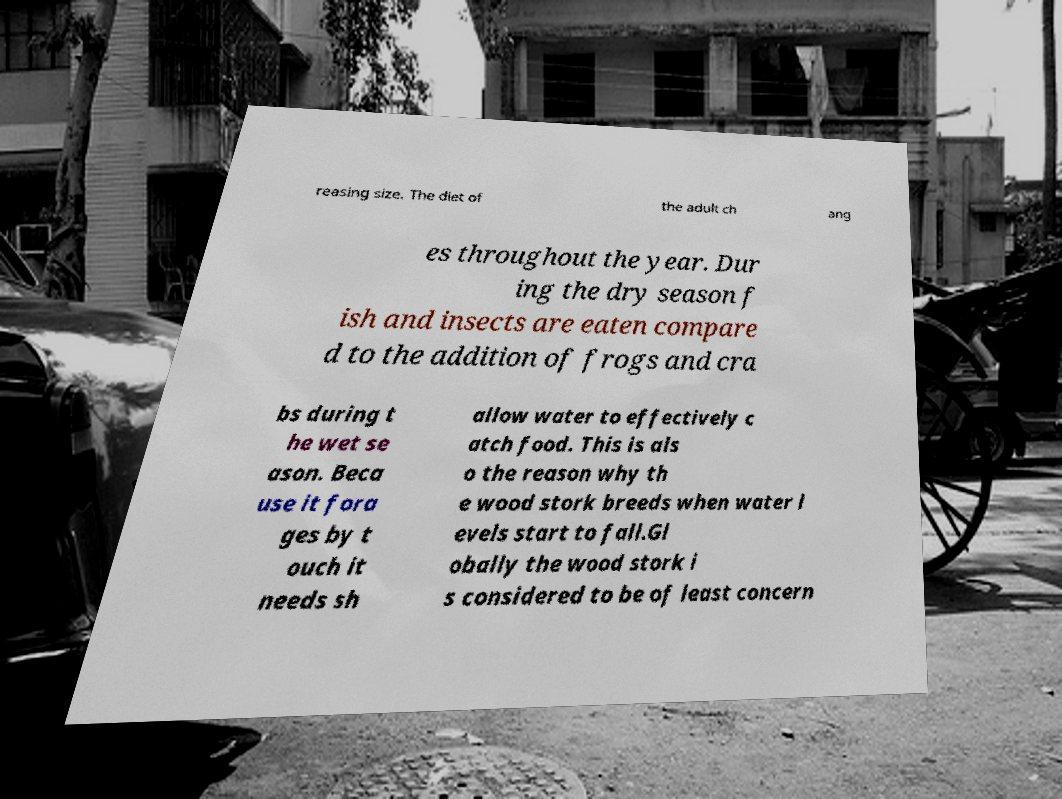I need the written content from this picture converted into text. Can you do that? reasing size. The diet of the adult ch ang es throughout the year. Dur ing the dry season f ish and insects are eaten compare d to the addition of frogs and cra bs during t he wet se ason. Beca use it fora ges by t ouch it needs sh allow water to effectively c atch food. This is als o the reason why th e wood stork breeds when water l evels start to fall.Gl obally the wood stork i s considered to be of least concern 